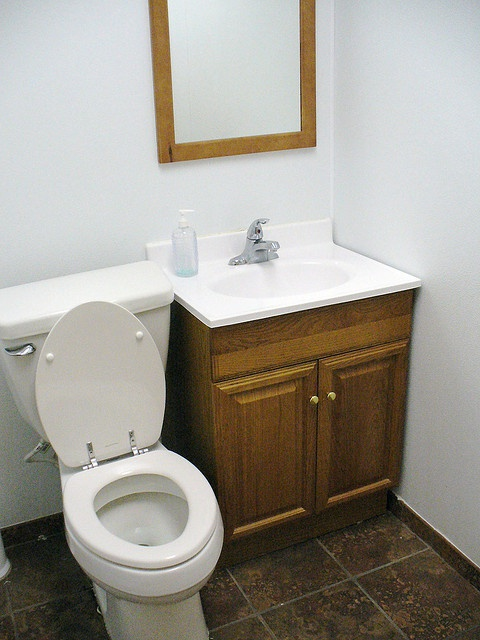Describe the objects in this image and their specific colors. I can see toilet in darkgray, lightgray, and gray tones, sink in darkgray, white, lightgray, and black tones, and bottle in darkgray, lightgray, and lightblue tones in this image. 